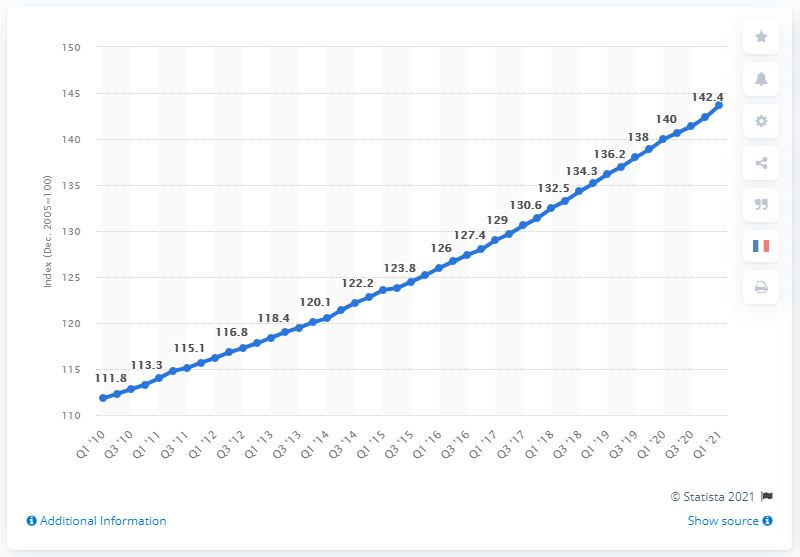Mention a couple of crucial points in this snapshot. The ECI (Employment-Population Ratio) in the first quarter of 2021 was 143.7%. 